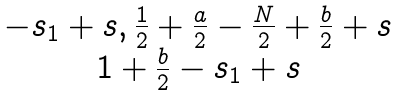<formula> <loc_0><loc_0><loc_500><loc_500>\begin{matrix} - s _ { 1 } + s , \frac { 1 } { 2 } + \frac { a } { 2 } - \frac { N } { 2 } + \frac { b } { 2 } + s \\ 1 + \frac { b } { 2 } - s _ { 1 } + s \end{matrix}</formula> 